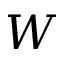<formula> <loc_0><loc_0><loc_500><loc_500>W</formula> 